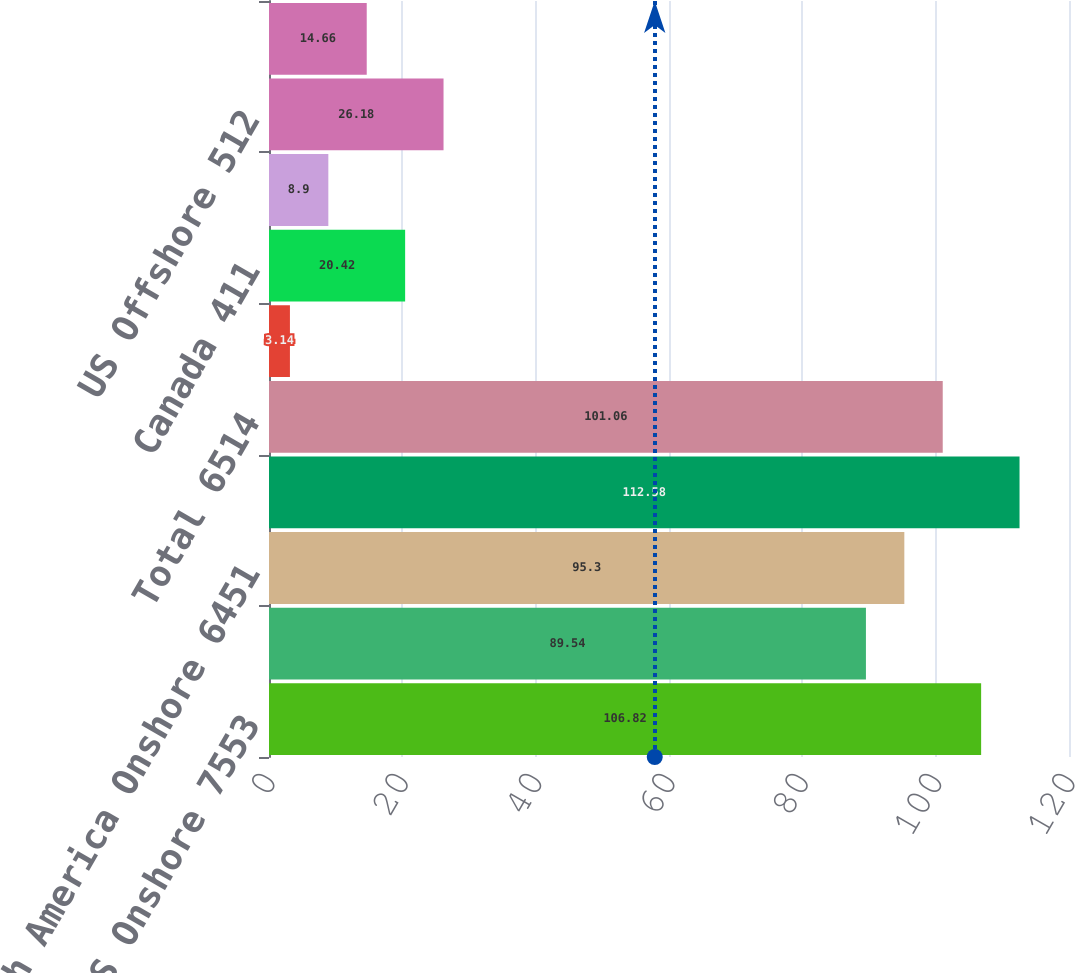Convert chart to OTSL. <chart><loc_0><loc_0><loc_500><loc_500><bar_chart><fcel>US Onshore 7553<fcel>Canada 5860<fcel>North America Onshore 6451<fcel>US Offshore 7781<fcel>Total 6514<fcel>US Onshore 373<fcel>Canada 411<fcel>North America Onshore 382<fcel>US Offshore 512<fcel>Total 384<nl><fcel>106.82<fcel>89.54<fcel>95.3<fcel>112.58<fcel>101.06<fcel>3.14<fcel>20.42<fcel>8.9<fcel>26.18<fcel>14.66<nl></chart> 